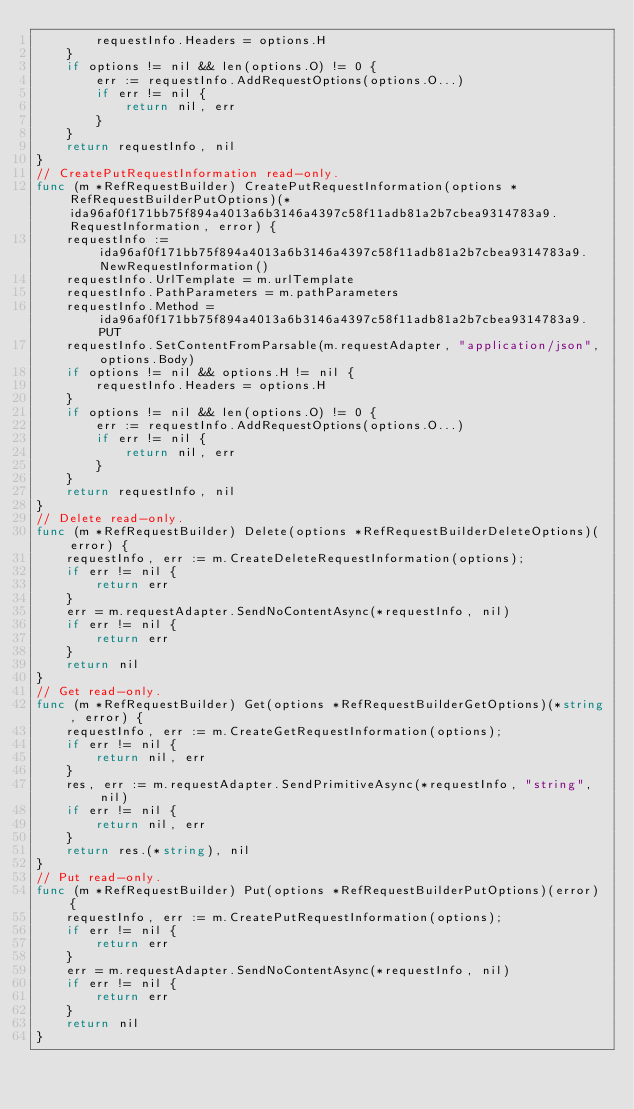<code> <loc_0><loc_0><loc_500><loc_500><_Go_>        requestInfo.Headers = options.H
    }
    if options != nil && len(options.O) != 0 {
        err := requestInfo.AddRequestOptions(options.O...)
        if err != nil {
            return nil, err
        }
    }
    return requestInfo, nil
}
// CreatePutRequestInformation read-only.
func (m *RefRequestBuilder) CreatePutRequestInformation(options *RefRequestBuilderPutOptions)(*ida96af0f171bb75f894a4013a6b3146a4397c58f11adb81a2b7cbea9314783a9.RequestInformation, error) {
    requestInfo := ida96af0f171bb75f894a4013a6b3146a4397c58f11adb81a2b7cbea9314783a9.NewRequestInformation()
    requestInfo.UrlTemplate = m.urlTemplate
    requestInfo.PathParameters = m.pathParameters
    requestInfo.Method = ida96af0f171bb75f894a4013a6b3146a4397c58f11adb81a2b7cbea9314783a9.PUT
    requestInfo.SetContentFromParsable(m.requestAdapter, "application/json", options.Body)
    if options != nil && options.H != nil {
        requestInfo.Headers = options.H
    }
    if options != nil && len(options.O) != 0 {
        err := requestInfo.AddRequestOptions(options.O...)
        if err != nil {
            return nil, err
        }
    }
    return requestInfo, nil
}
// Delete read-only.
func (m *RefRequestBuilder) Delete(options *RefRequestBuilderDeleteOptions)(error) {
    requestInfo, err := m.CreateDeleteRequestInformation(options);
    if err != nil {
        return err
    }
    err = m.requestAdapter.SendNoContentAsync(*requestInfo, nil)
    if err != nil {
        return err
    }
    return nil
}
// Get read-only.
func (m *RefRequestBuilder) Get(options *RefRequestBuilderGetOptions)(*string, error) {
    requestInfo, err := m.CreateGetRequestInformation(options);
    if err != nil {
        return nil, err
    }
    res, err := m.requestAdapter.SendPrimitiveAsync(*requestInfo, "string", nil)
    if err != nil {
        return nil, err
    }
    return res.(*string), nil
}
// Put read-only.
func (m *RefRequestBuilder) Put(options *RefRequestBuilderPutOptions)(error) {
    requestInfo, err := m.CreatePutRequestInformation(options);
    if err != nil {
        return err
    }
    err = m.requestAdapter.SendNoContentAsync(*requestInfo, nil)
    if err != nil {
        return err
    }
    return nil
}
</code> 